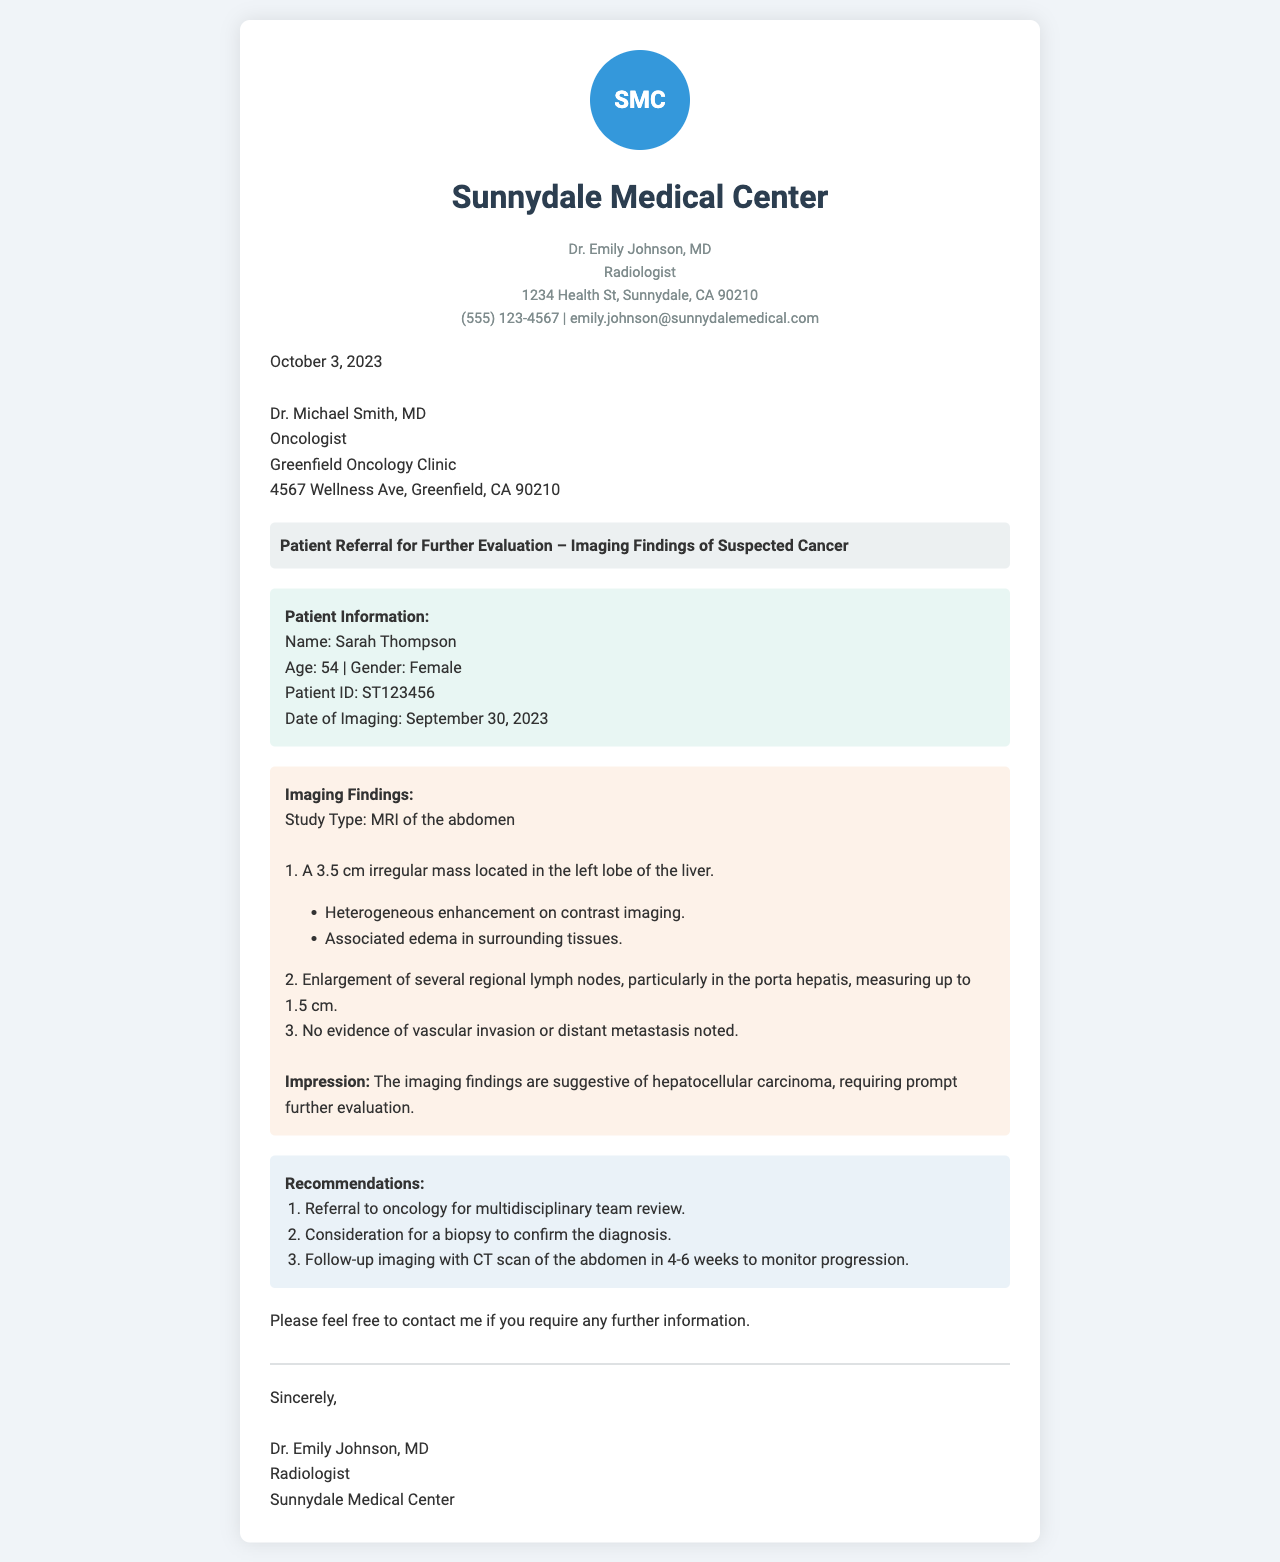What is the patient's name? The patient's name is stated in the patient information section of the document.
Answer: Sarah Thompson What is the age of the patient? The patient's age is included in the patient information section.
Answer: 54 What type of imaging study was performed? The type of imaging study is specified in the imaging findings section.
Answer: MRI of the abdomen What is the size of the irregular mass in the liver? The size of the mass is detailed in the imaging findings.
Answer: 3.5 cm What is the suggested diagnosis from the imaging findings? The diagnosis is stated in the impression within the imaging findings.
Answer: Hepatocellular carcinoma What are the recommendations for further evaluation? The recommendations section includes a list of actions.
Answer: Referral to oncology Who is the sender of the letter? The sender's name is at the top of the document under sender information.
Answer: Dr. Emily Johnson What is the recipient's title? The recipient's title is mentioned in the recipient section of the letter.
Answer: Oncologist What is the date of imaging? The date of imaging is included in the patient information section.
Answer: September 30, 2023 What is the purpose of this letter? The purpose is indicated in the subject line of the letter.
Answer: Patient Referral for Further Evaluation 